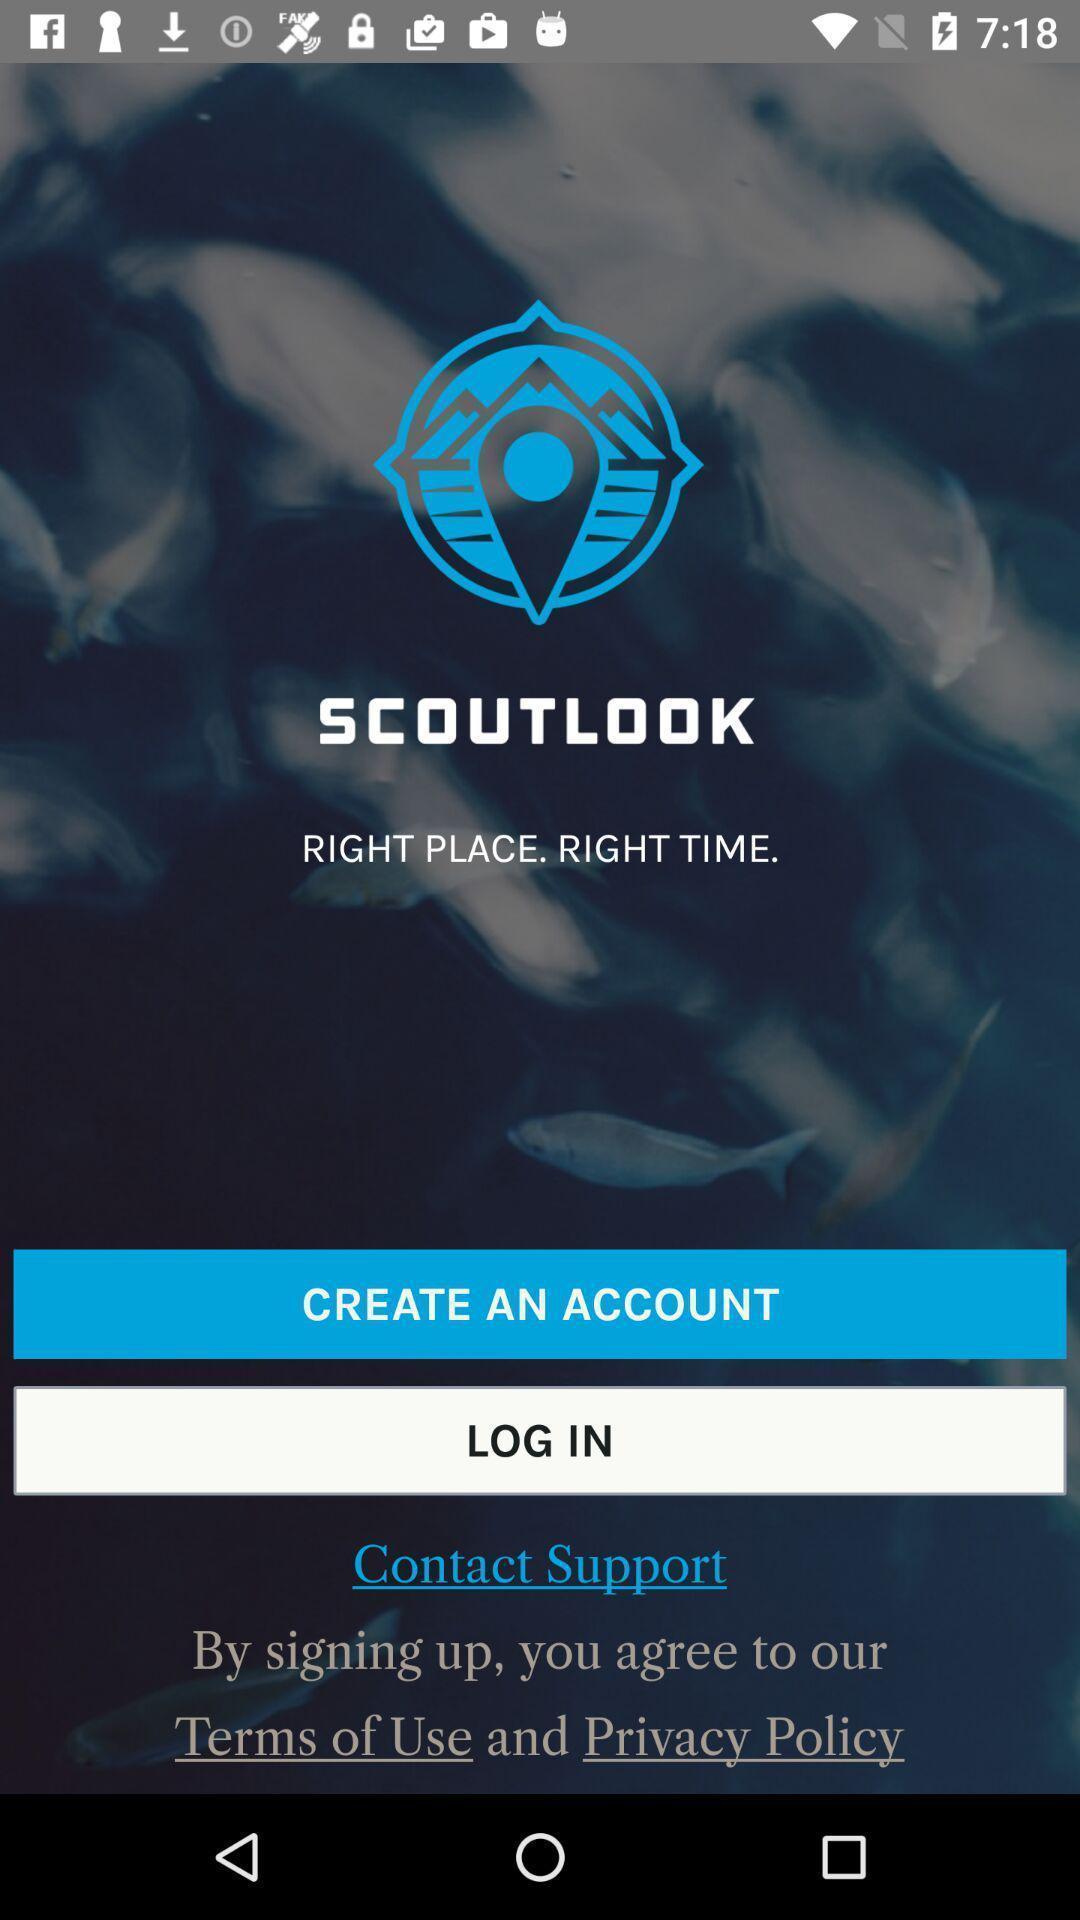Provide a description of this screenshot. Welcome page of weather app. 